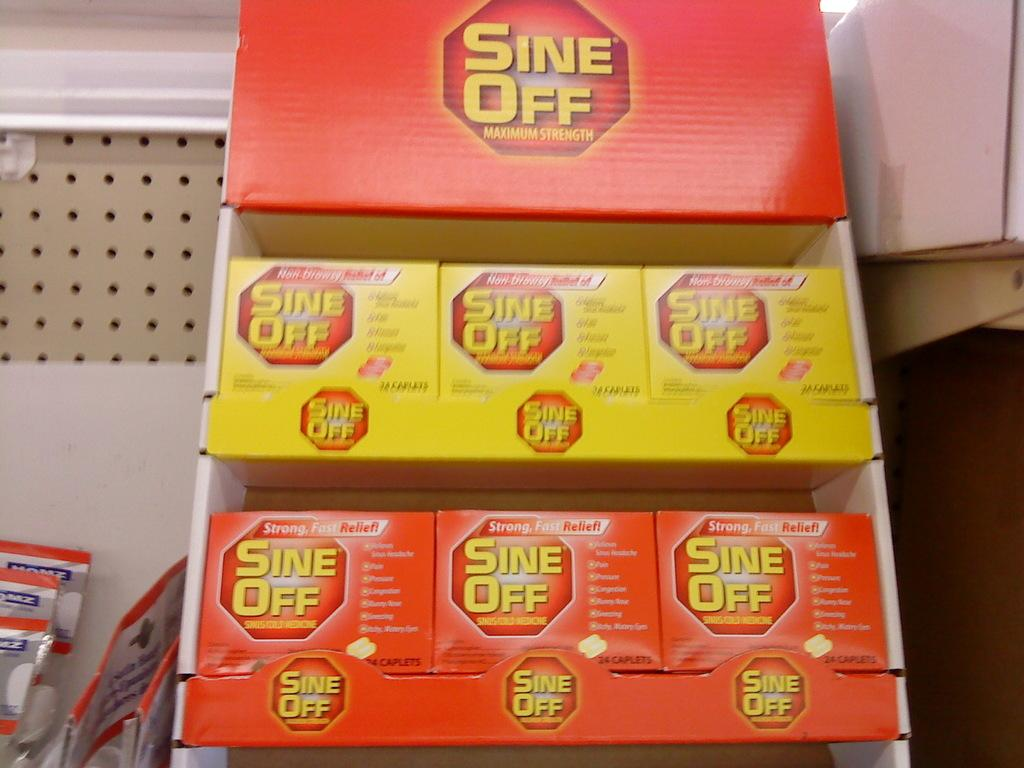<image>
Create a compact narrative representing the image presented. a box full of boxes that are all labeled 'sine off' 